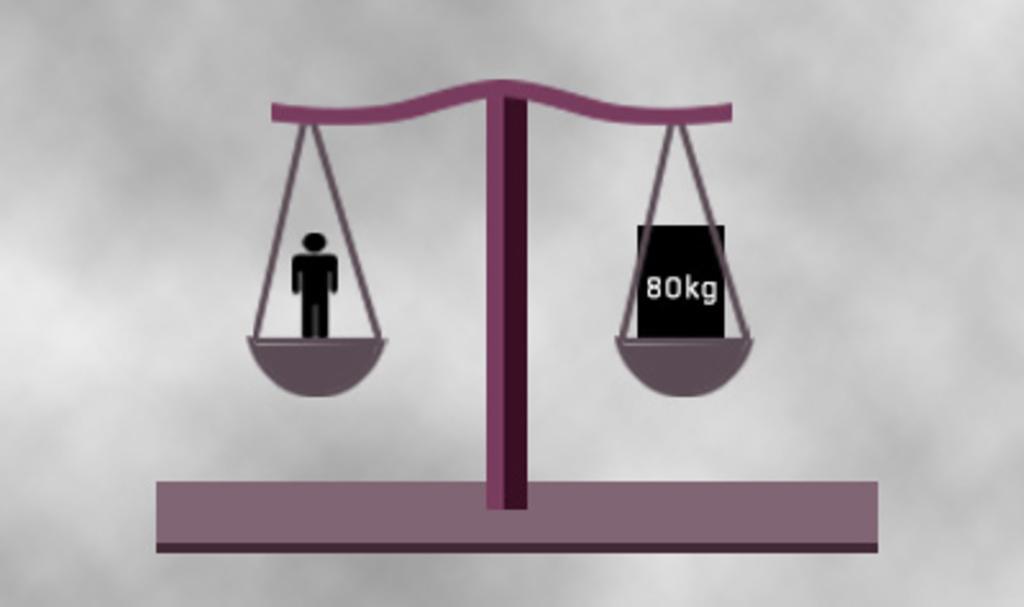In one or two sentences, can you explain what this image depicts? In this image we can see horizontal balance and logo of a person. 